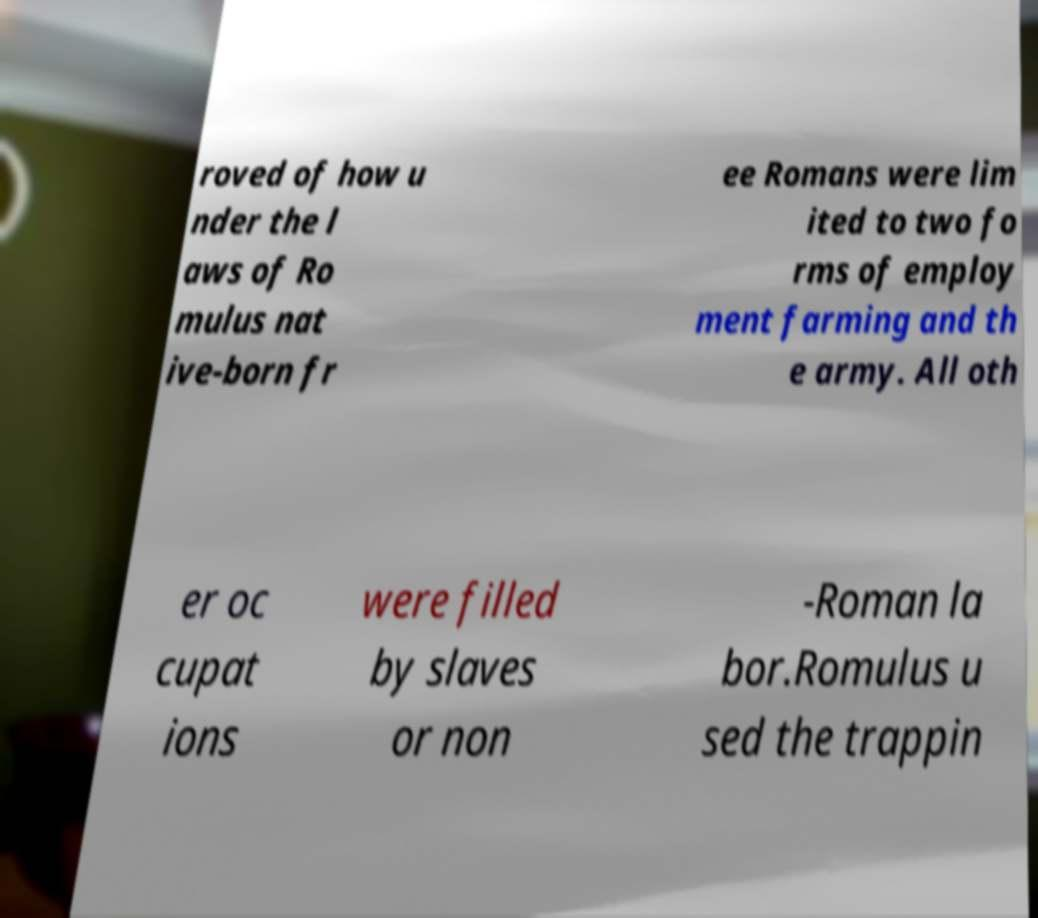I need the written content from this picture converted into text. Can you do that? roved of how u nder the l aws of Ro mulus nat ive-born fr ee Romans were lim ited to two fo rms of employ ment farming and th e army. All oth er oc cupat ions were filled by slaves or non -Roman la bor.Romulus u sed the trappin 